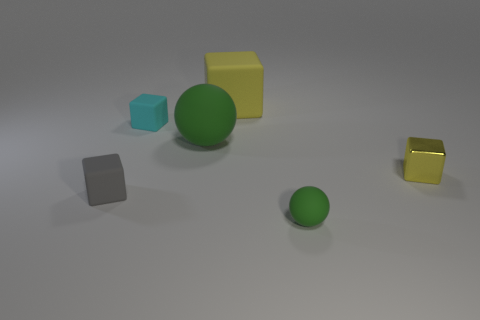Subtract all big rubber blocks. How many blocks are left? 3 Add 3 large blocks. How many objects exist? 9 Subtract all yellow blocks. How many blocks are left? 2 Subtract 1 spheres. How many spheres are left? 1 Subtract all yellow cylinders. How many yellow cubes are left? 2 Subtract all cubes. How many objects are left? 2 Subtract all big matte blocks. Subtract all big green balls. How many objects are left? 4 Add 2 tiny rubber balls. How many tiny rubber balls are left? 3 Add 5 tiny yellow objects. How many tiny yellow objects exist? 6 Subtract 0 gray cylinders. How many objects are left? 6 